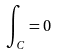Convert formula to latex. <formula><loc_0><loc_0><loc_500><loc_500>\int _ { C } = 0</formula> 